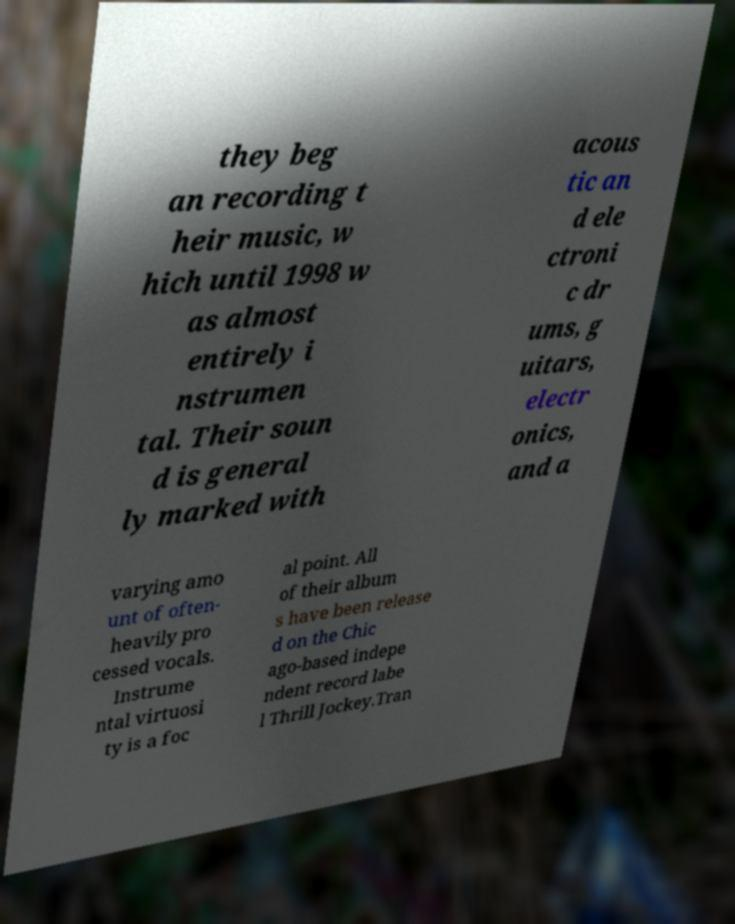Can you accurately transcribe the text from the provided image for me? they beg an recording t heir music, w hich until 1998 w as almost entirely i nstrumen tal. Their soun d is general ly marked with acous tic an d ele ctroni c dr ums, g uitars, electr onics, and a varying amo unt of often- heavily pro cessed vocals. Instrume ntal virtuosi ty is a foc al point. All of their album s have been release d on the Chic ago-based indepe ndent record labe l Thrill Jockey.Tran 